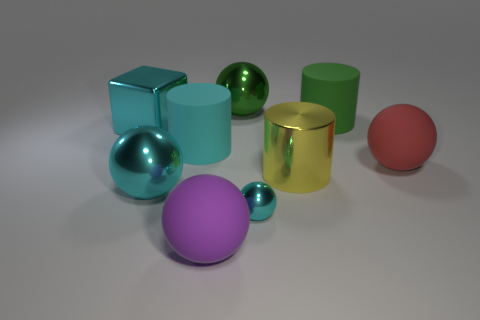Subtract all cyan balls. How many were subtracted if there are1cyan balls left? 1 Subtract all big green metallic balls. How many balls are left? 4 Subtract 1 cylinders. How many cylinders are left? 2 Subtract all red balls. How many balls are left? 4 Subtract all blocks. How many objects are left? 8 Add 6 green things. How many green things are left? 8 Add 9 large green matte cylinders. How many large green matte cylinders exist? 10 Subtract 0 yellow blocks. How many objects are left? 9 Subtract all gray cylinders. Subtract all blue spheres. How many cylinders are left? 3 Subtract all cyan shiny things. Subtract all small cyan objects. How many objects are left? 5 